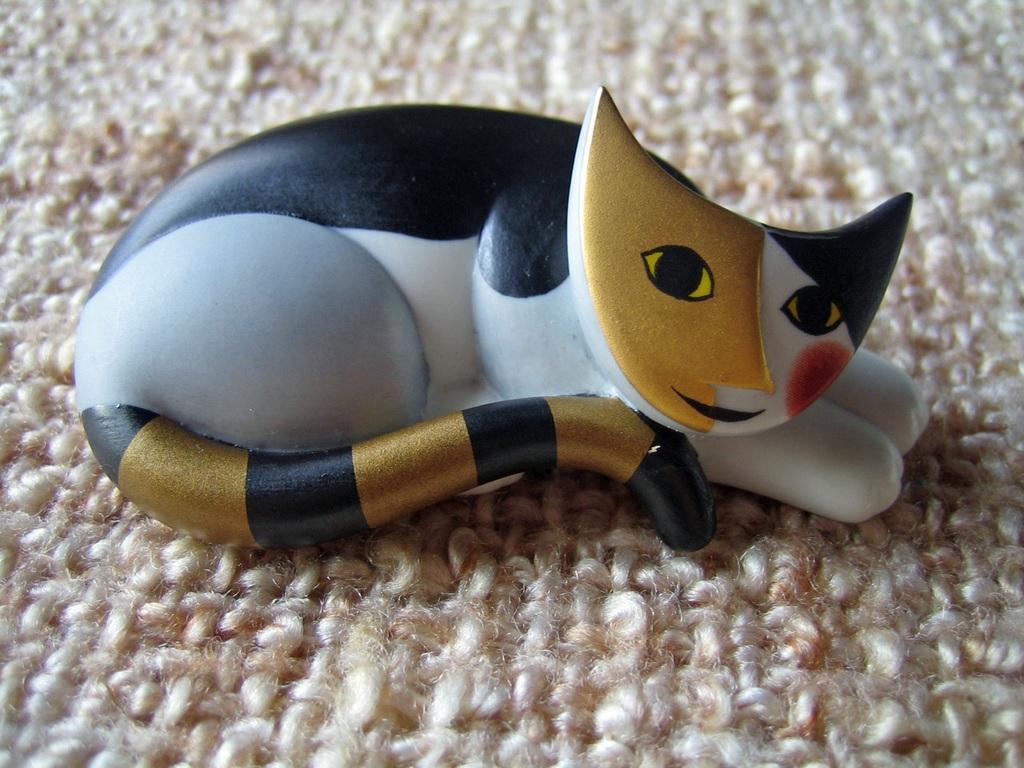Please provide a concise description of this image. In this image, in the middle, we can see a toy. In the background, we can see a mat. 